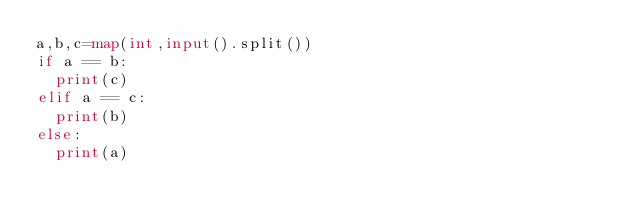<code> <loc_0><loc_0><loc_500><loc_500><_Python_>a,b,c=map(int,input().split())
if a == b:
  print(c)
elif a == c:
  print(b)
else:
  print(a)</code> 